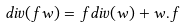<formula> <loc_0><loc_0><loc_500><loc_500>d i v ( f w ) = f d i v ( w ) + w . f</formula> 